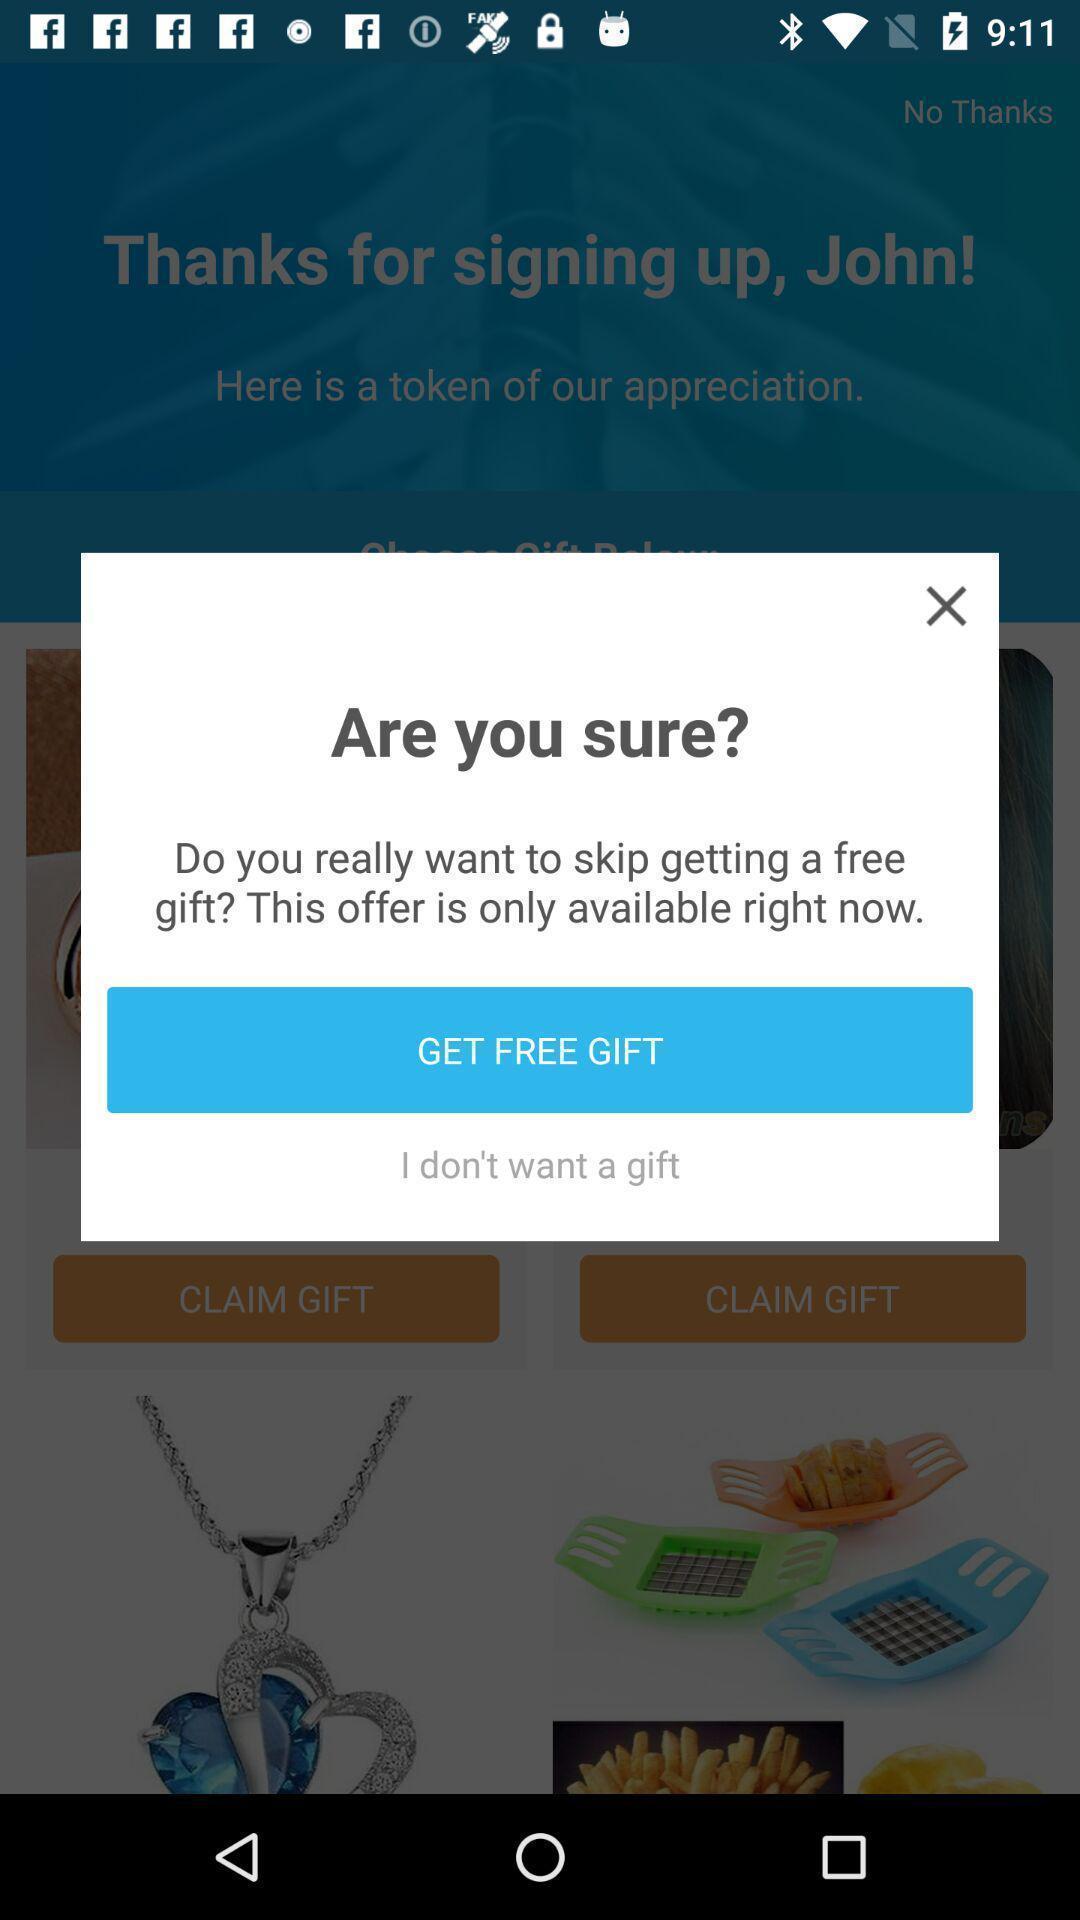Summarize the information in this screenshot. Pop up page showing option to avail free girt. 